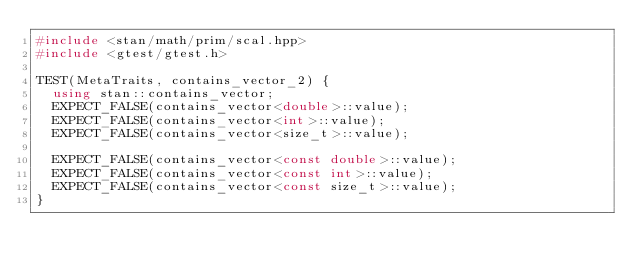Convert code to text. <code><loc_0><loc_0><loc_500><loc_500><_C++_>#include <stan/math/prim/scal.hpp>
#include <gtest/gtest.h>

TEST(MetaTraits, contains_vector_2) {
  using stan::contains_vector;
  EXPECT_FALSE(contains_vector<double>::value);
  EXPECT_FALSE(contains_vector<int>::value);
  EXPECT_FALSE(contains_vector<size_t>::value);

  EXPECT_FALSE(contains_vector<const double>::value);
  EXPECT_FALSE(contains_vector<const int>::value);
  EXPECT_FALSE(contains_vector<const size_t>::value);
}
</code> 